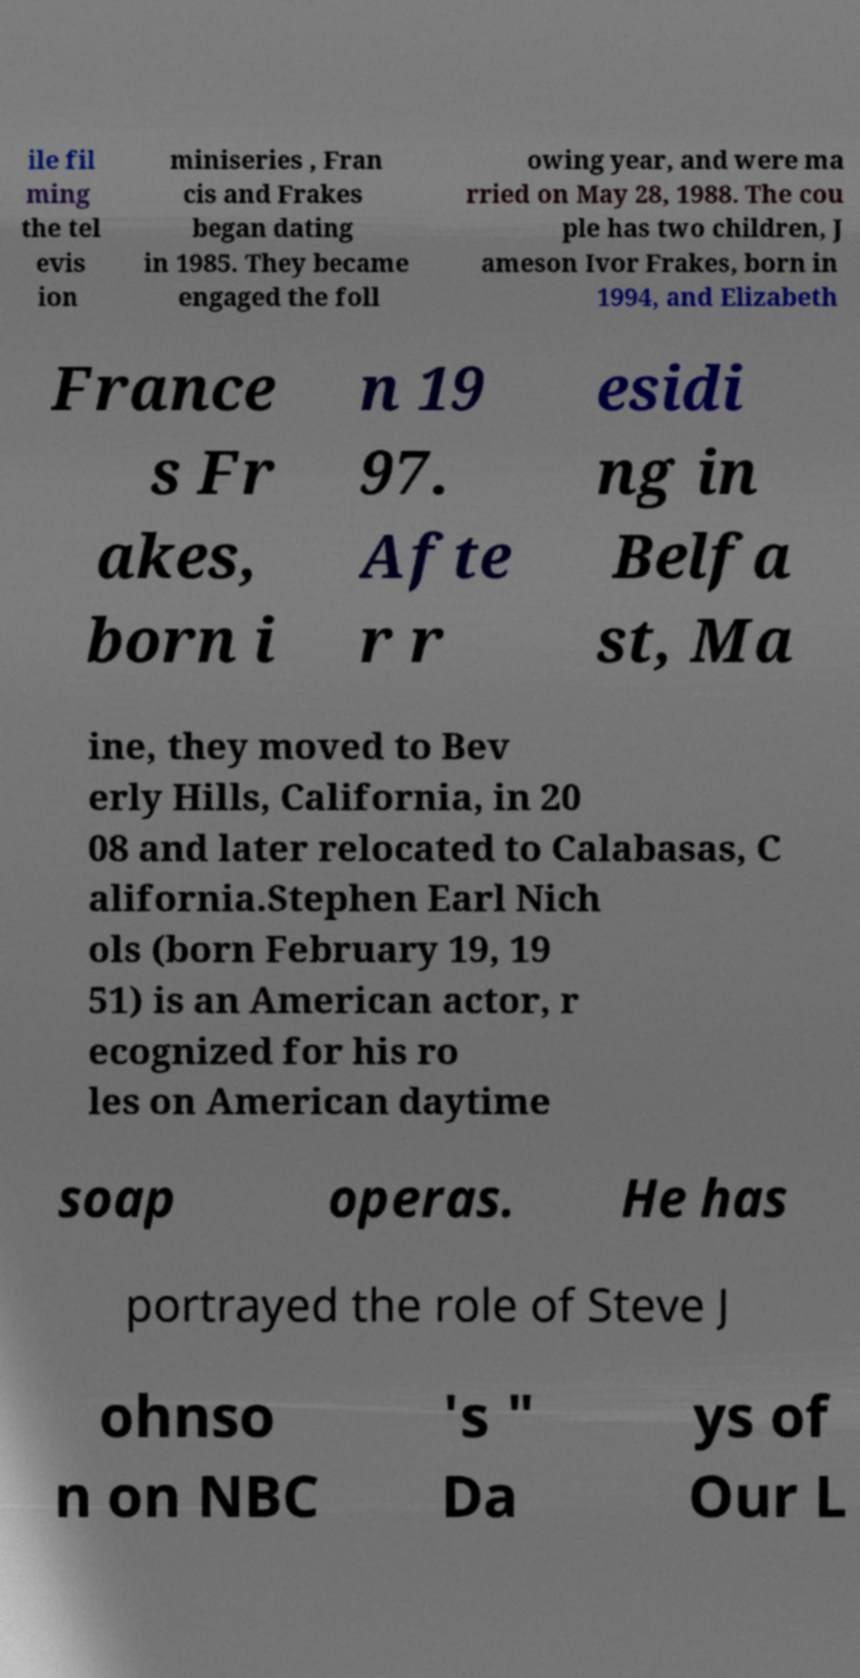Can you read and provide the text displayed in the image?This photo seems to have some interesting text. Can you extract and type it out for me? ile fil ming the tel evis ion miniseries , Fran cis and Frakes began dating in 1985. They became engaged the foll owing year, and were ma rried on May 28, 1988. The cou ple has two children, J ameson Ivor Frakes, born in 1994, and Elizabeth France s Fr akes, born i n 19 97. Afte r r esidi ng in Belfa st, Ma ine, they moved to Bev erly Hills, California, in 20 08 and later relocated to Calabasas, C alifornia.Stephen Earl Nich ols (born February 19, 19 51) is an American actor, r ecognized for his ro les on American daytime soap operas. He has portrayed the role of Steve J ohnso n on NBC 's " Da ys of Our L 